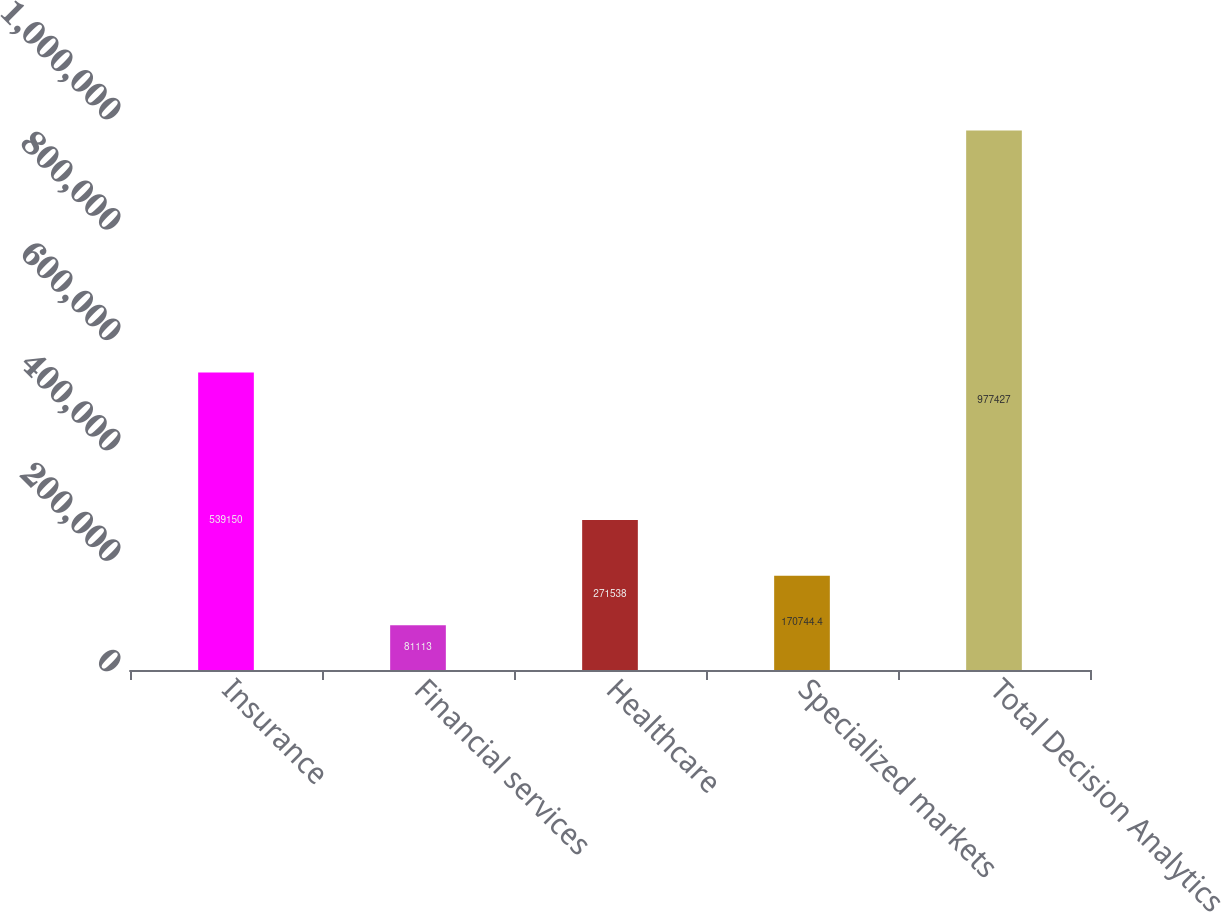<chart> <loc_0><loc_0><loc_500><loc_500><bar_chart><fcel>Insurance<fcel>Financial services<fcel>Healthcare<fcel>Specialized markets<fcel>Total Decision Analytics<nl><fcel>539150<fcel>81113<fcel>271538<fcel>170744<fcel>977427<nl></chart> 